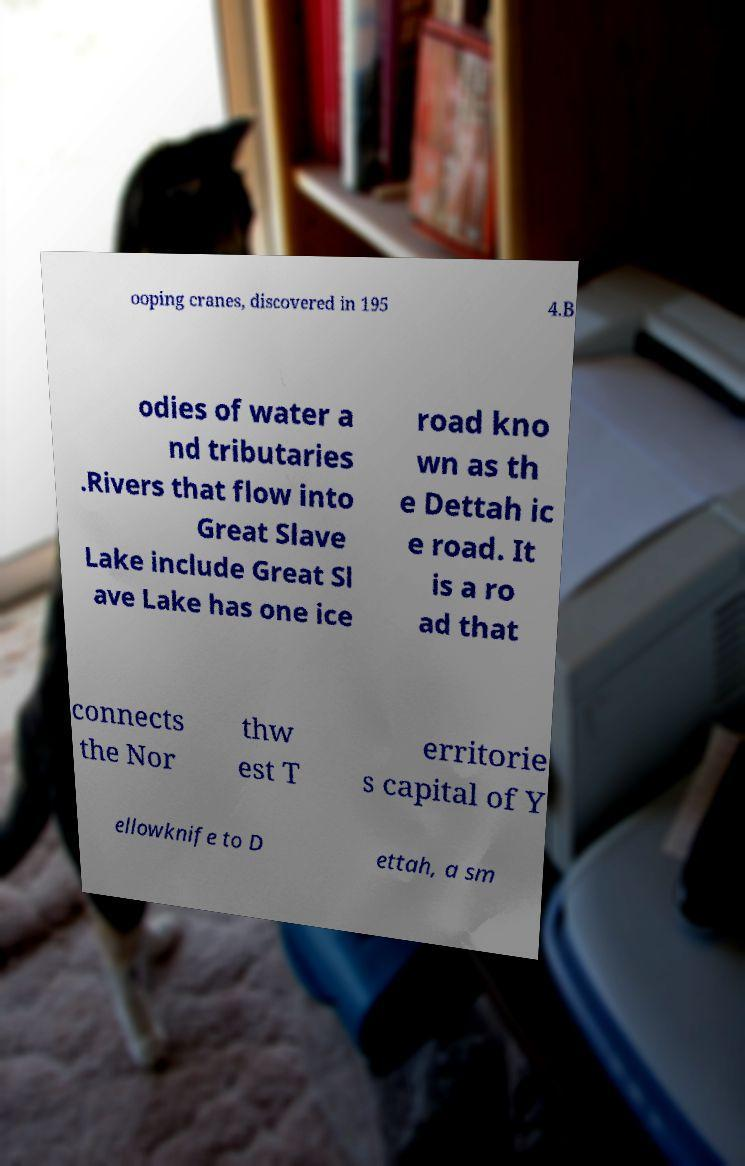Can you read and provide the text displayed in the image?This photo seems to have some interesting text. Can you extract and type it out for me? ooping cranes, discovered in 195 4.B odies of water a nd tributaries .Rivers that flow into Great Slave Lake include Great Sl ave Lake has one ice road kno wn as th e Dettah ic e road. It is a ro ad that connects the Nor thw est T erritorie s capital of Y ellowknife to D ettah, a sm 